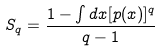Convert formula to latex. <formula><loc_0><loc_0><loc_500><loc_500>S _ { q } = \frac { 1 - \int d x [ p ( x ) ] ^ { q } } { q - 1 }</formula> 